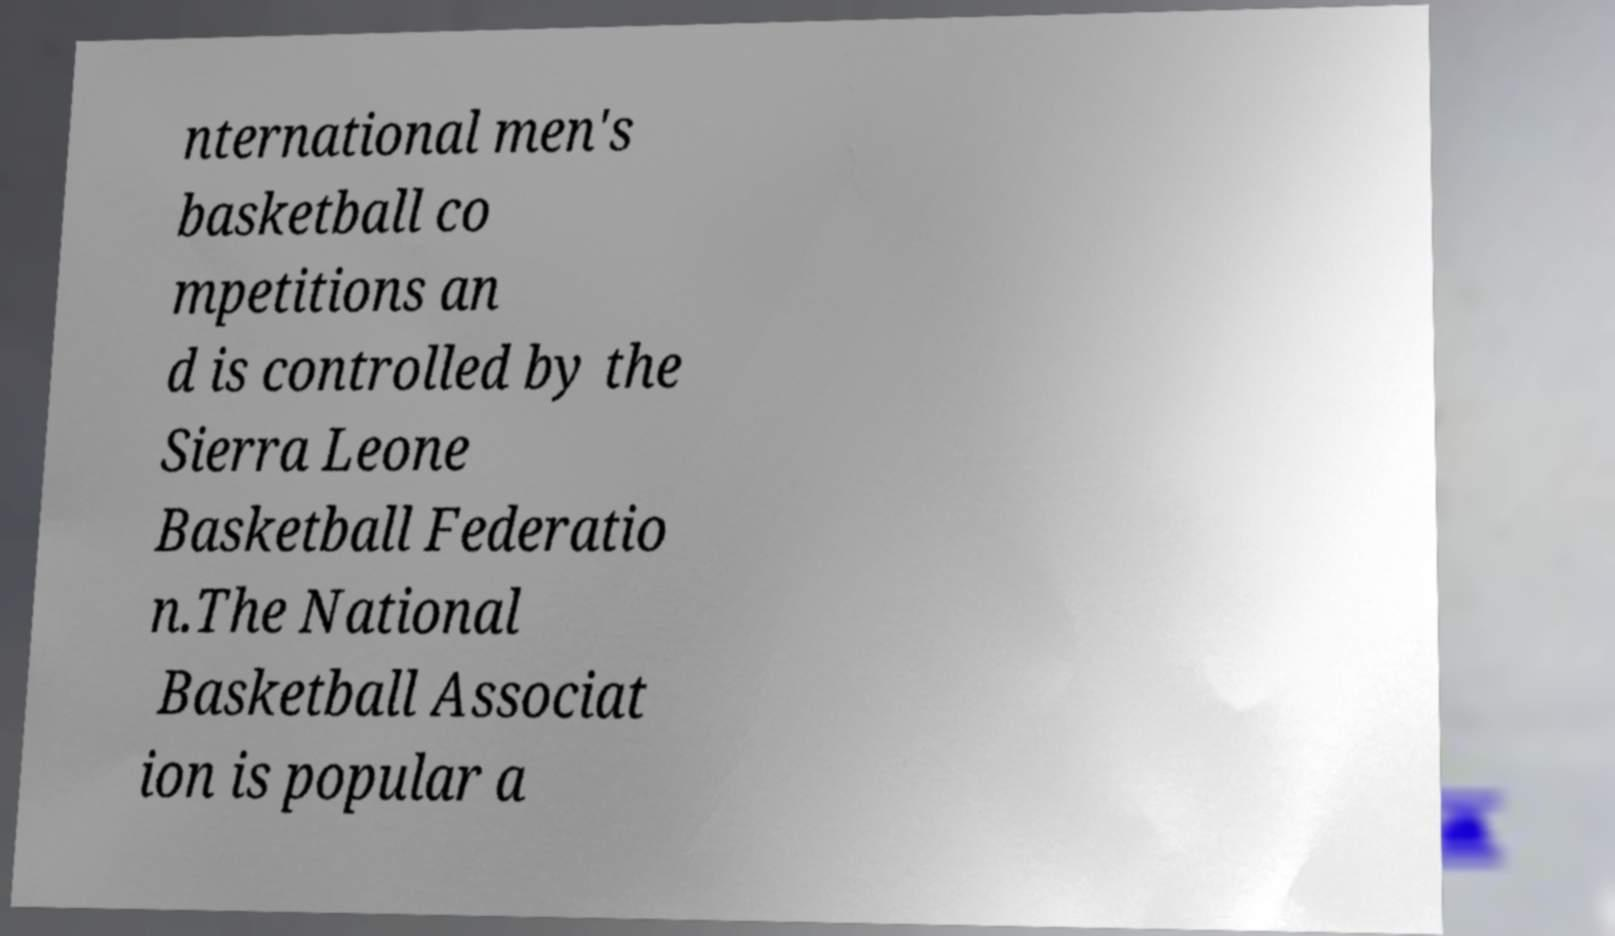What messages or text are displayed in this image? I need them in a readable, typed format. nternational men's basketball co mpetitions an d is controlled by the Sierra Leone Basketball Federatio n.The National Basketball Associat ion is popular a 